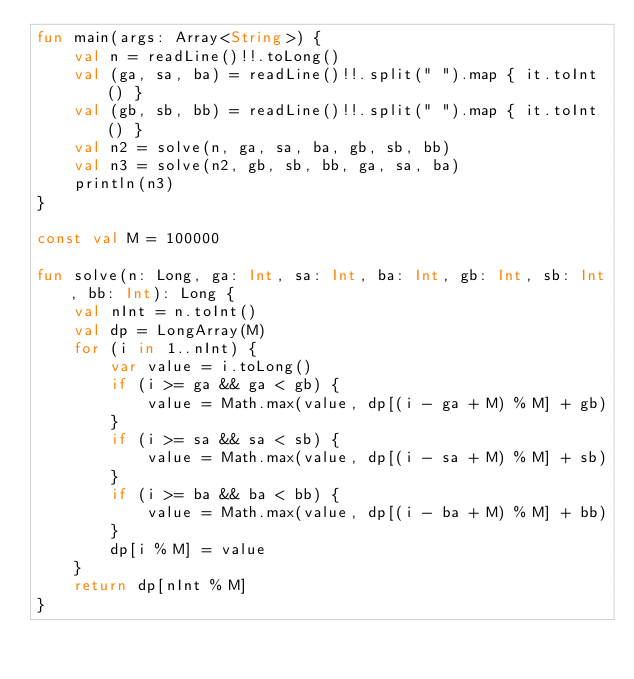<code> <loc_0><loc_0><loc_500><loc_500><_Kotlin_>fun main(args: Array<String>) {
    val n = readLine()!!.toLong()
    val (ga, sa, ba) = readLine()!!.split(" ").map { it.toInt() }
    val (gb, sb, bb) = readLine()!!.split(" ").map { it.toInt() }
    val n2 = solve(n, ga, sa, ba, gb, sb, bb)
    val n3 = solve(n2, gb, sb, bb, ga, sa, ba)
    println(n3)
}

const val M = 100000

fun solve(n: Long, ga: Int, sa: Int, ba: Int, gb: Int, sb: Int, bb: Int): Long {
    val nInt = n.toInt()
    val dp = LongArray(M)
    for (i in 1..nInt) {
        var value = i.toLong()
        if (i >= ga && ga < gb) {
            value = Math.max(value, dp[(i - ga + M) % M] + gb)
        }
        if (i >= sa && sa < sb) {
            value = Math.max(value, dp[(i - sa + M) % M] + sb)
        }
        if (i >= ba && ba < bb) {
            value = Math.max(value, dp[(i - ba + M) % M] + bb)
        }
        dp[i % M] = value
    }
    return dp[nInt % M]
}
</code> 